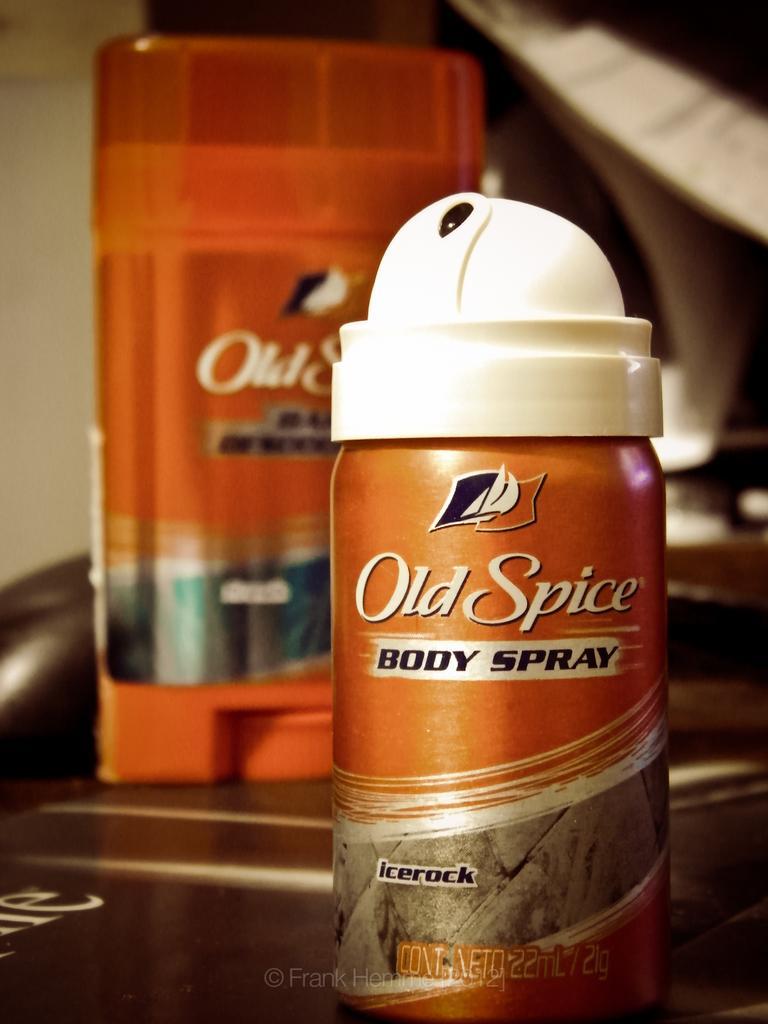How would you summarize this image in a sentence or two? In the center of the image we can see one table. On the table, we can see bottles and a few other objects. On the bottle, it is written as "Old Spice". At the bottom of the image, there is a watermark. In the background there is a wall and a few other objects. 